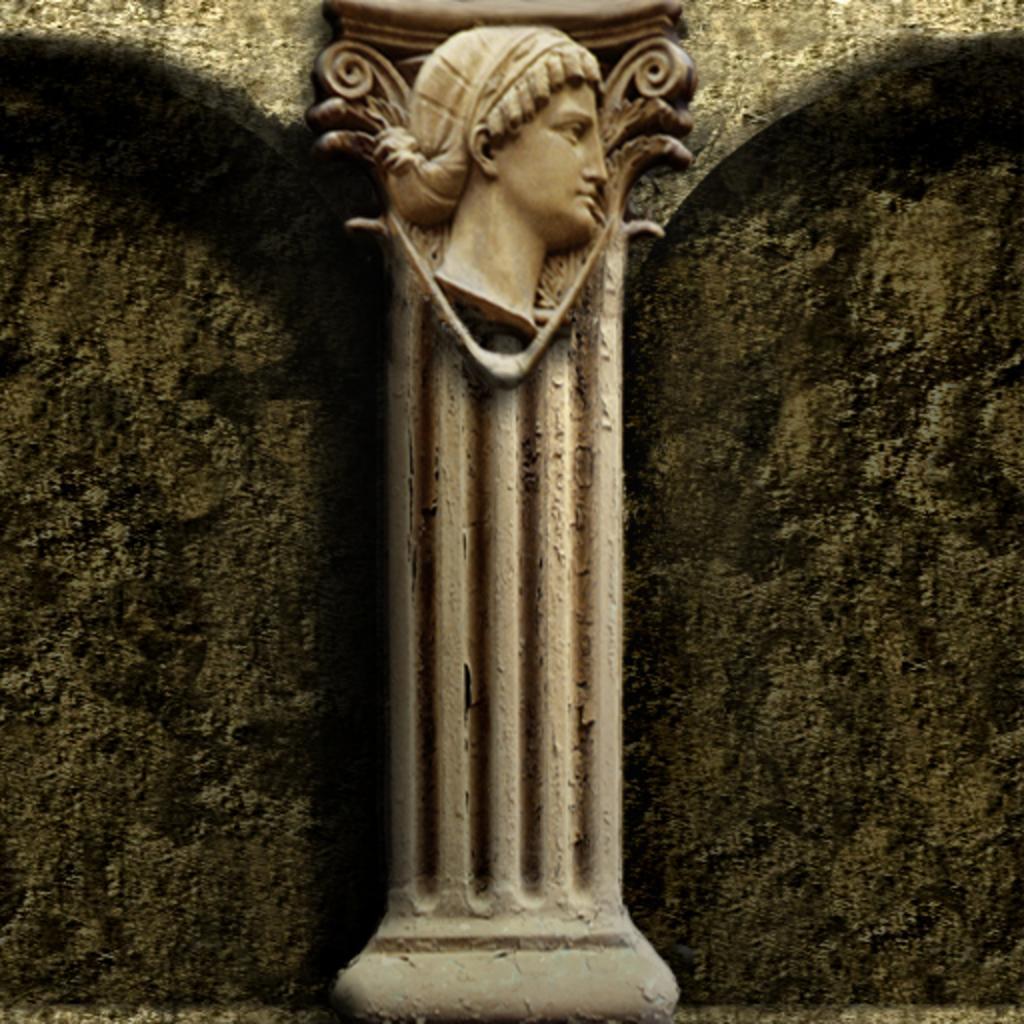Could you give a brief overview of what you see in this image? In the image we can see a pillar and a sculpture in the pillar. 